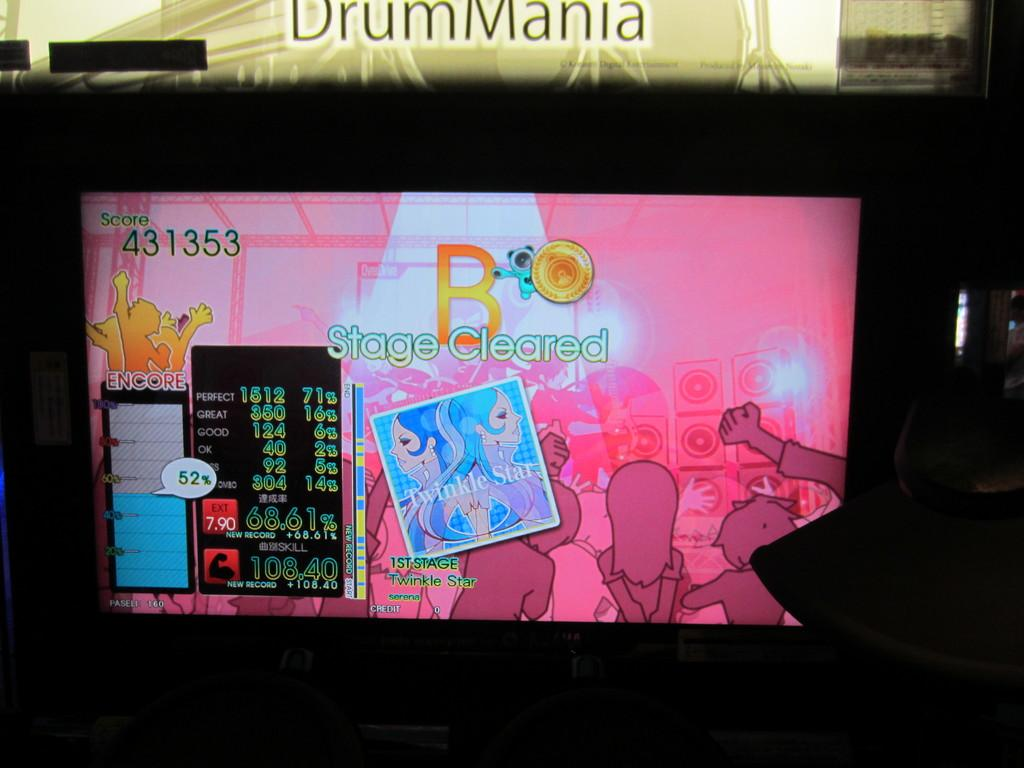<image>
Provide a brief description of the given image. The word DrumMania over a screen with a lot of pink on it 